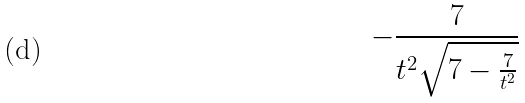<formula> <loc_0><loc_0><loc_500><loc_500>- \frac { 7 } { t ^ { 2 } \sqrt { 7 - \frac { 7 } { t ^ { 2 } } } }</formula> 